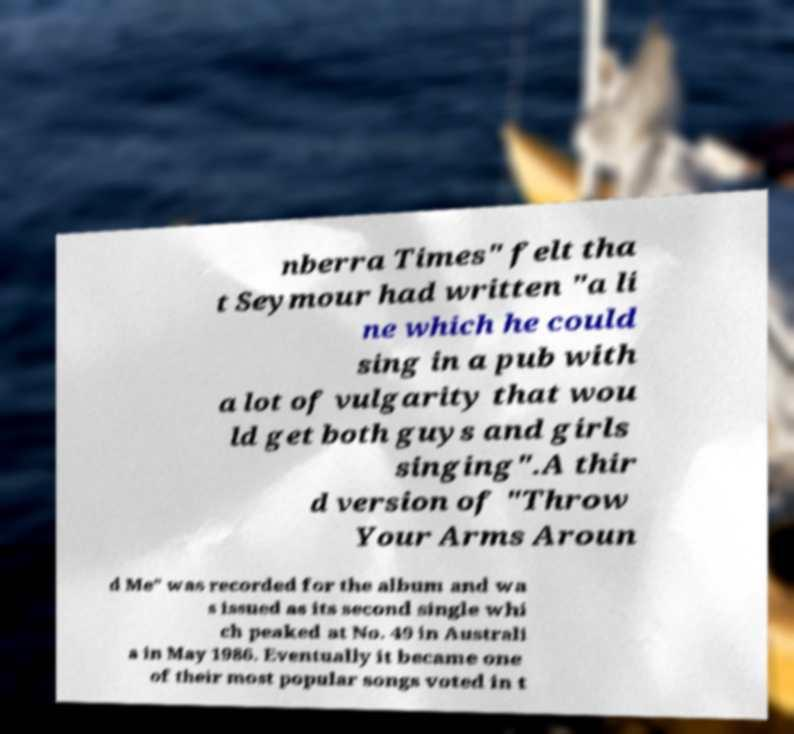Please read and relay the text visible in this image. What does it say? nberra Times" felt tha t Seymour had written "a li ne which he could sing in a pub with a lot of vulgarity that wou ld get both guys and girls singing".A thir d version of "Throw Your Arms Aroun d Me" was recorded for the album and wa s issued as its second single whi ch peaked at No. 49 in Australi a in May 1986. Eventually it became one of their most popular songs voted in t 